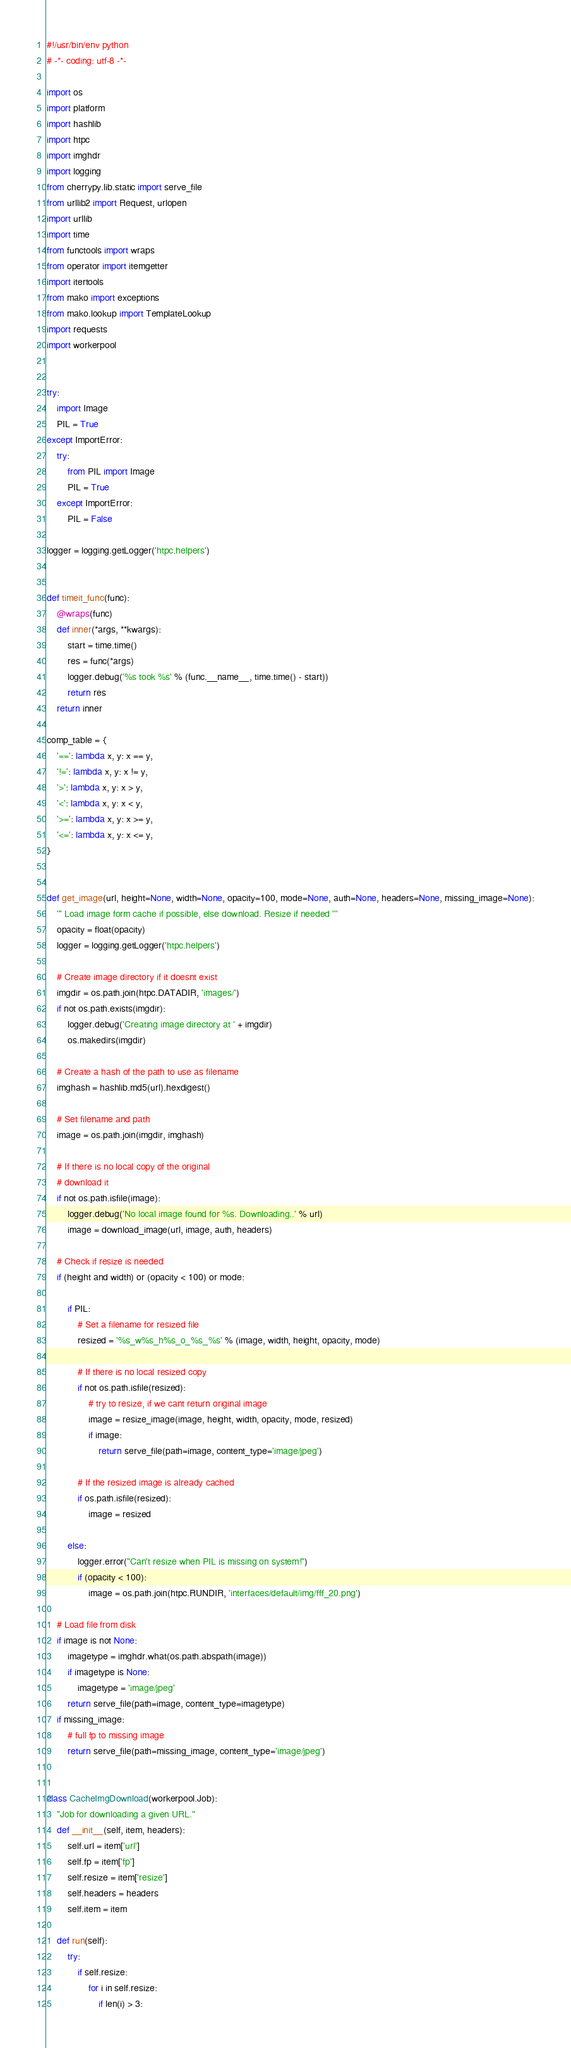<code> <loc_0><loc_0><loc_500><loc_500><_Python_>#!/usr/bin/env python
# -*- coding: utf-8 -*-

import os
import platform
import hashlib
import htpc
import imghdr
import logging
from cherrypy.lib.static import serve_file
from urllib2 import Request, urlopen
import urllib
import time
from functools import wraps
from operator import itemgetter
import itertools
from mako import exceptions
from mako.lookup import TemplateLookup
import requests
import workerpool


try:
    import Image
    PIL = True
except ImportError:
    try:
        from PIL import Image
        PIL = True
    except ImportError:
        PIL = False

logger = logging.getLogger('htpc.helpers')


def timeit_func(func):
    @wraps(func)
    def inner(*args, **kwargs):
        start = time.time()
        res = func(*args)
        logger.debug('%s took %s' % (func.__name__, time.time() - start))
        return res
    return inner

comp_table = {
    '==': lambda x, y: x == y,
    '!=': lambda x, y: x != y,
    '>': lambda x, y: x > y,
    '<': lambda x, y: x < y,
    '>=': lambda x, y: x >= y,
    '<=': lambda x, y: x <= y,
}


def get_image(url, height=None, width=None, opacity=100, mode=None, auth=None, headers=None, missing_image=None):
    ''' Load image form cache if possible, else download. Resize if needed '''
    opacity = float(opacity)
    logger = logging.getLogger('htpc.helpers')

    # Create image directory if it doesnt exist
    imgdir = os.path.join(htpc.DATADIR, 'images/')
    if not os.path.exists(imgdir):
        logger.debug('Creating image directory at ' + imgdir)
        os.makedirs(imgdir)

    # Create a hash of the path to use as filename
    imghash = hashlib.md5(url).hexdigest()

    # Set filename and path
    image = os.path.join(imgdir, imghash)

    # If there is no local copy of the original
    # download it
    if not os.path.isfile(image):
        logger.debug('No local image found for %s. Downloading..' % url)
        image = download_image(url, image, auth, headers)

    # Check if resize is needed
    if (height and width) or (opacity < 100) or mode:

        if PIL:
            # Set a filename for resized file
            resized = '%s_w%s_h%s_o_%s_%s' % (image, width, height, opacity, mode)

            # If there is no local resized copy
            if not os.path.isfile(resized):
                # try to resize, if we cant return original image
                image = resize_image(image, height, width, opacity, mode, resized)
                if image:
                    return serve_file(path=image, content_type='image/jpeg')

            # If the resized image is already cached
            if os.path.isfile(resized):
                image = resized

        else:
            logger.error("Can't resize when PIL is missing on system!")
            if (opacity < 100):
                image = os.path.join(htpc.RUNDIR, 'interfaces/default/img/fff_20.png')

    # Load file from disk
    if image is not None:
        imagetype = imghdr.what(os.path.abspath(image))
        if imagetype is None:
            imagetype = 'image/jpeg'
        return serve_file(path=image, content_type=imagetype)
    if missing_image:
        # full fp to missing image
        return serve_file(path=missing_image, content_type='image/jpeg')


class CacheImgDownload(workerpool.Job):
    "Job for downloading a given URL."
    def __init__(self, item, headers):
        self.url = item['url']
        self.fp = item['fp']
        self.resize = item['resize']
        self.headers = headers
        self.item = item

    def run(self):
        try:
            if self.resize:
                for i in self.resize:
                    if len(i) > 3:</code> 